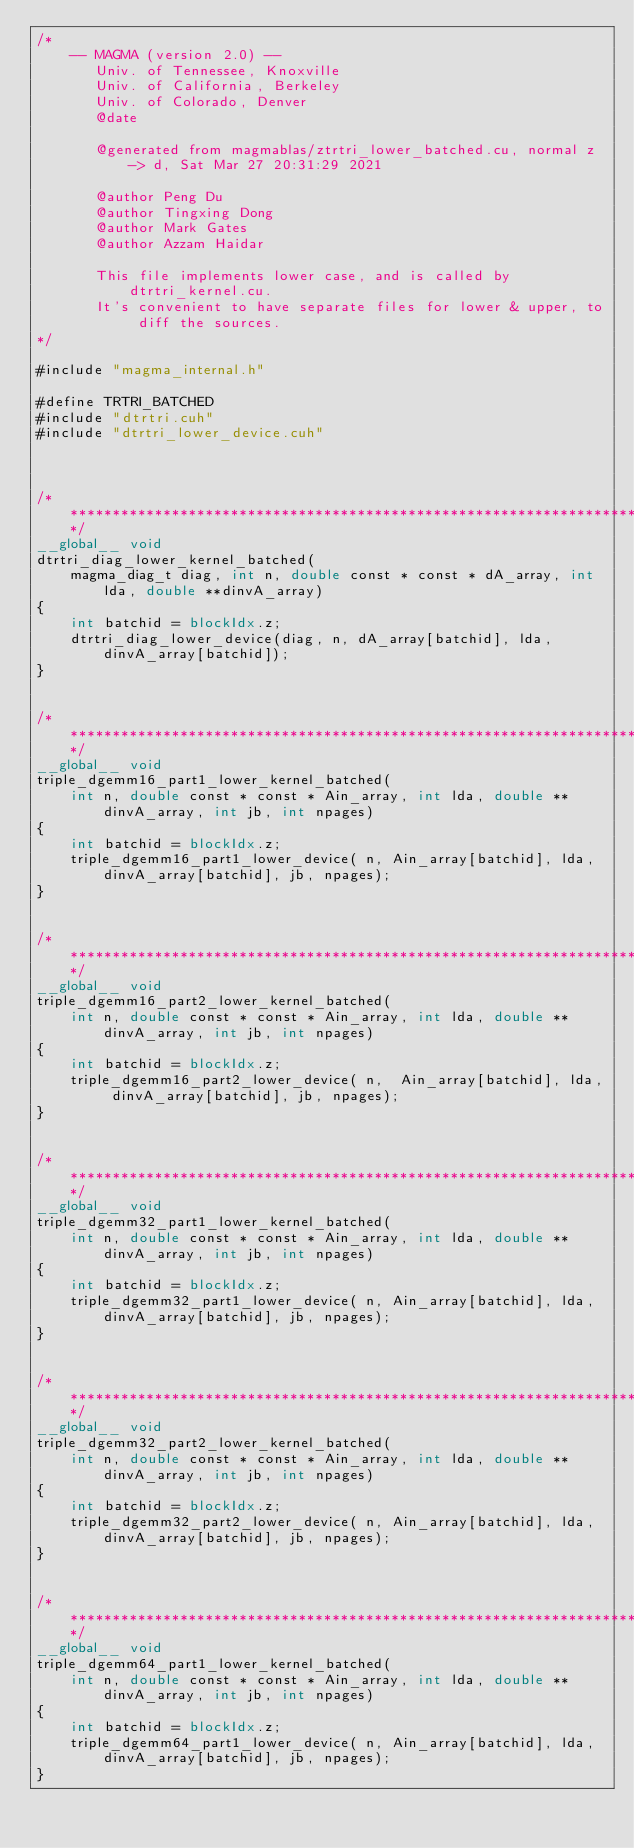<code> <loc_0><loc_0><loc_500><loc_500><_Cuda_>/*
    -- MAGMA (version 2.0) --
       Univ. of Tennessee, Knoxville
       Univ. of California, Berkeley
       Univ. of Colorado, Denver
       @date

       @generated from magmablas/ztrtri_lower_batched.cu, normal z -> d, Sat Mar 27 20:31:29 2021

       @author Peng Du
       @author Tingxing Dong
       @author Mark Gates
       @author Azzam Haidar
       
       This file implements lower case, and is called by dtrtri_kernel.cu.
       It's convenient to have separate files for lower & upper, to diff the sources.
*/

#include "magma_internal.h"

#define TRTRI_BATCHED
#include "dtrtri.cuh"
#include "dtrtri_lower_device.cuh"



/******************************************************************************/
__global__ void
dtrtri_diag_lower_kernel_batched(
    magma_diag_t diag, int n, double const * const * dA_array, int lda, double **dinvA_array)
{
    int batchid = blockIdx.z;
    dtrtri_diag_lower_device(diag, n, dA_array[batchid], lda, dinvA_array[batchid]);
}


/******************************************************************************/
__global__ void
triple_dgemm16_part1_lower_kernel_batched(
    int n, double const * const * Ain_array, int lda, double **dinvA_array, int jb, int npages)
{
    int batchid = blockIdx.z;
    triple_dgemm16_part1_lower_device( n, Ain_array[batchid], lda, dinvA_array[batchid], jb, npages);
}


/******************************************************************************/
__global__ void
triple_dgemm16_part2_lower_kernel_batched(
    int n, double const * const * Ain_array, int lda, double **dinvA_array, int jb, int npages)
{
    int batchid = blockIdx.z;
    triple_dgemm16_part2_lower_device( n,  Ain_array[batchid], lda, dinvA_array[batchid], jb, npages);
}


/******************************************************************************/
__global__ void
triple_dgemm32_part1_lower_kernel_batched(
    int n, double const * const * Ain_array, int lda, double **dinvA_array, int jb, int npages)
{
    int batchid = blockIdx.z;
    triple_dgemm32_part1_lower_device( n, Ain_array[batchid], lda, dinvA_array[batchid], jb, npages);
}


/******************************************************************************/
__global__ void
triple_dgemm32_part2_lower_kernel_batched(
    int n, double const * const * Ain_array, int lda, double **dinvA_array, int jb, int npages)
{
    int batchid = blockIdx.z;
    triple_dgemm32_part2_lower_device( n, Ain_array[batchid], lda, dinvA_array[batchid], jb, npages);
}


/******************************************************************************/
__global__ void
triple_dgemm64_part1_lower_kernel_batched(
    int n, double const * const * Ain_array, int lda, double **dinvA_array, int jb, int npages)
{
    int batchid = blockIdx.z;
    triple_dgemm64_part1_lower_device( n, Ain_array[batchid], lda, dinvA_array[batchid], jb, npages);
}

</code> 